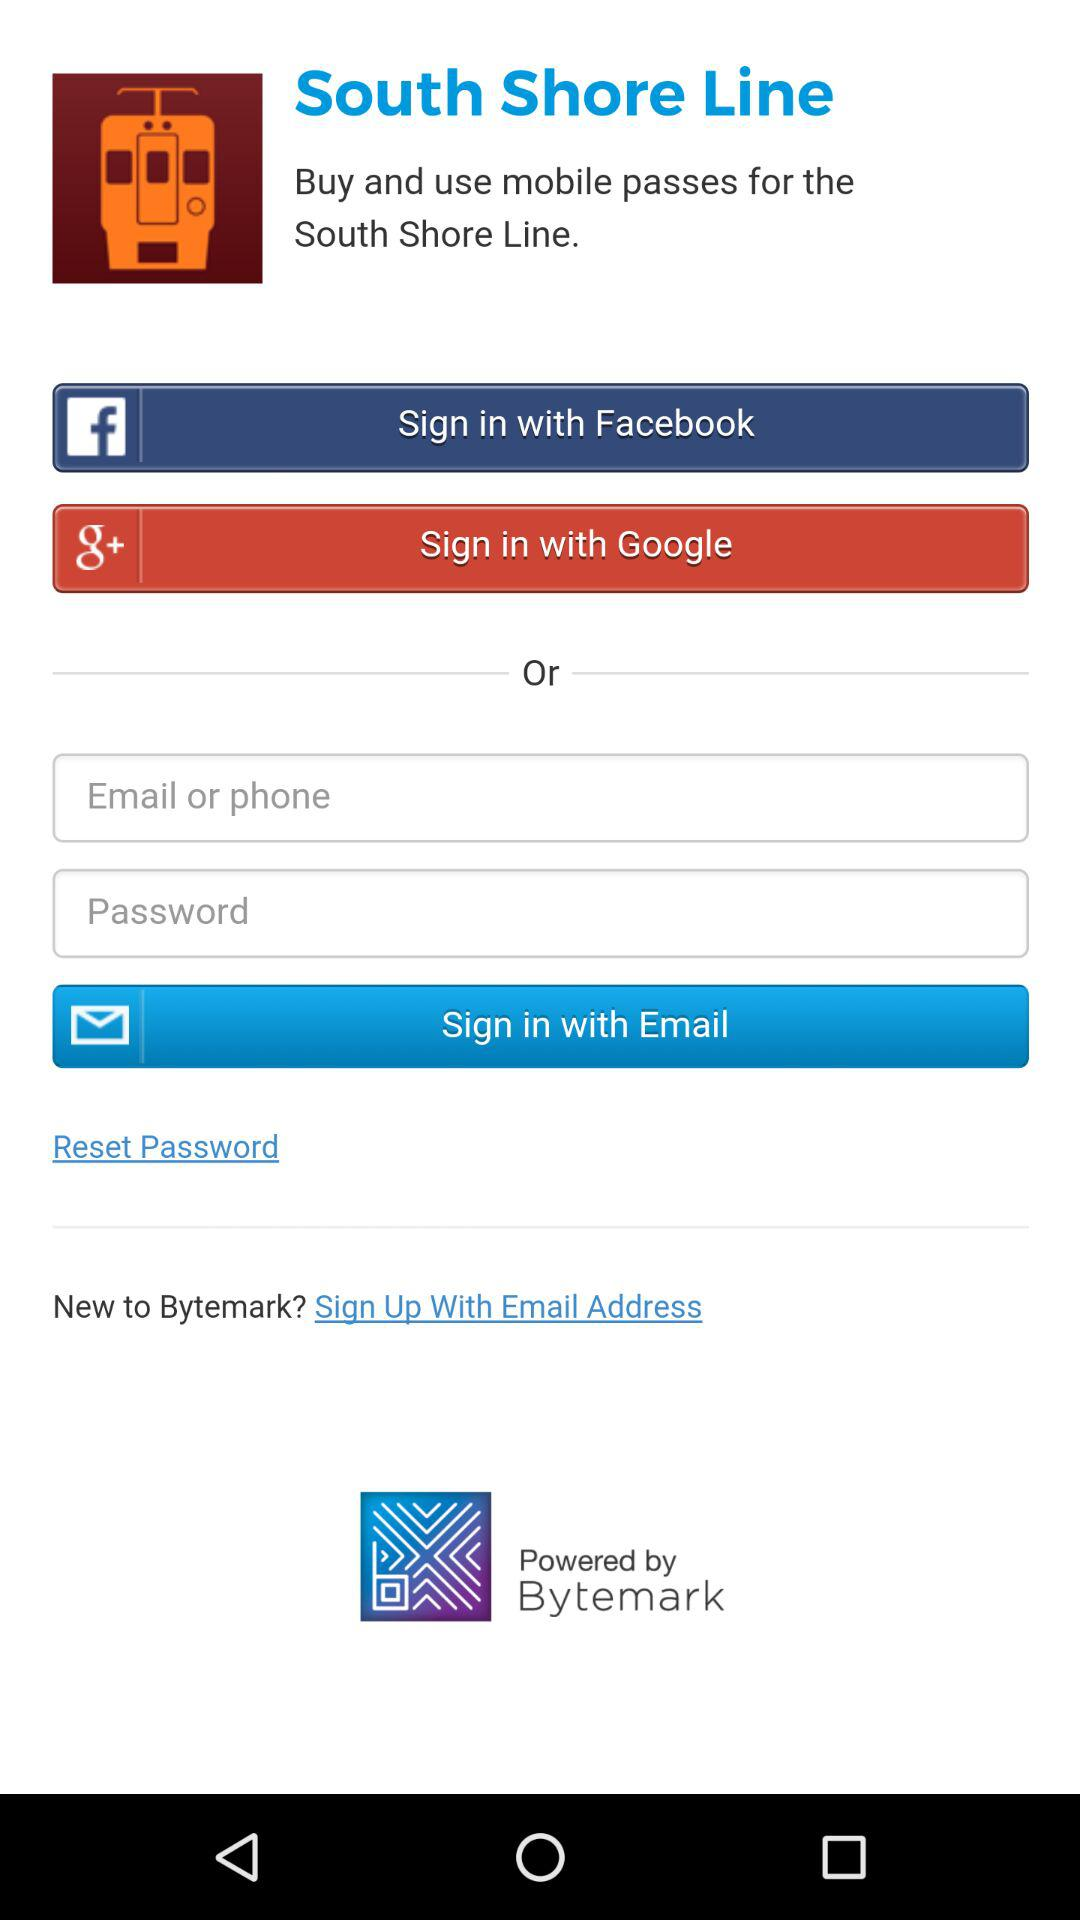What applications can be used to sign up? The applications are "Facebook", "Google" and "Email". 